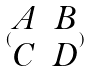Convert formula to latex. <formula><loc_0><loc_0><loc_500><loc_500>( \begin{matrix} A & B \\ C & D \end{matrix} )</formula> 